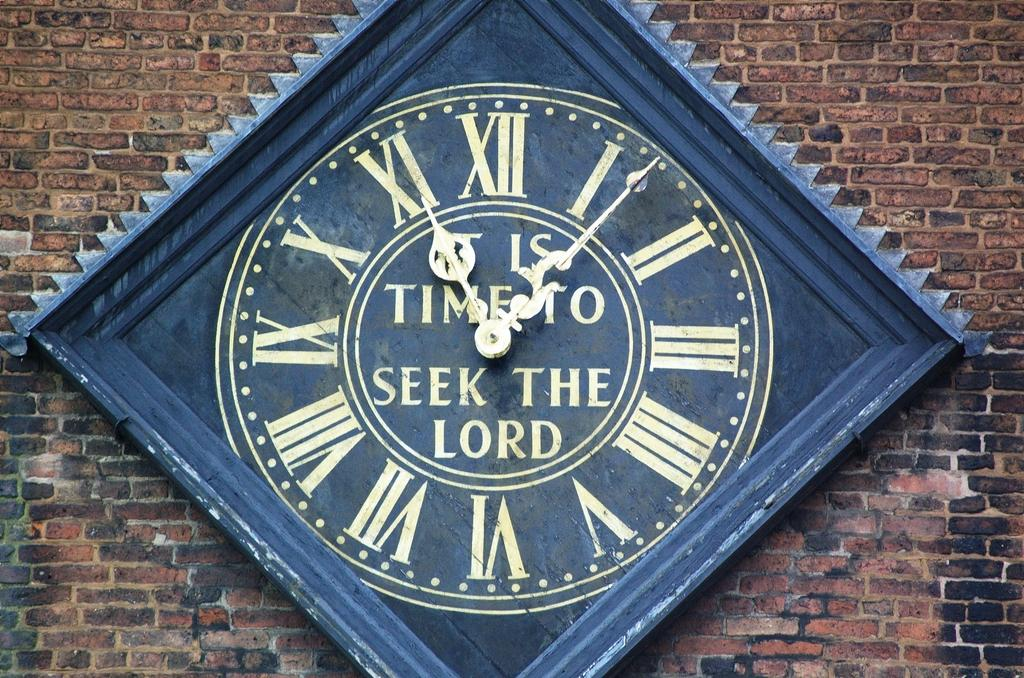Provide a one-sentence caption for the provided image. A clock that states it is time to seek the lord. 